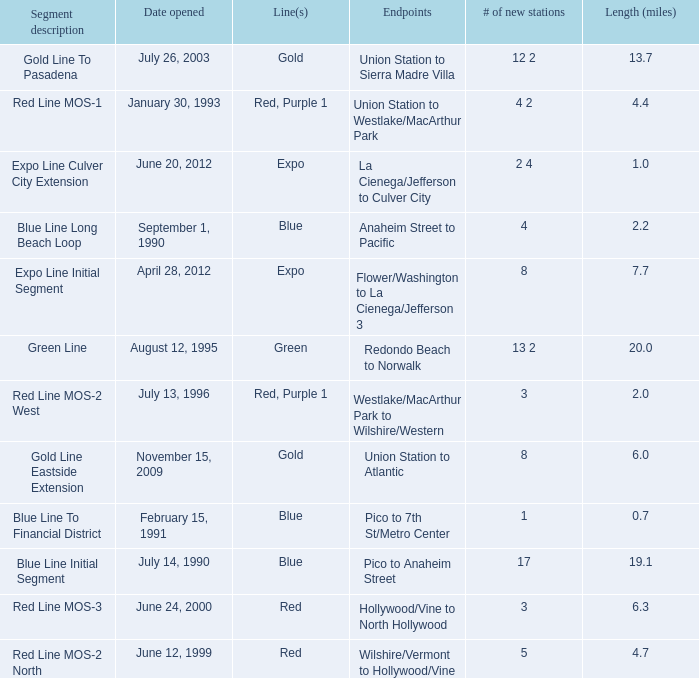How many news stations opened on the date of June 24, 2000? 3.0. 